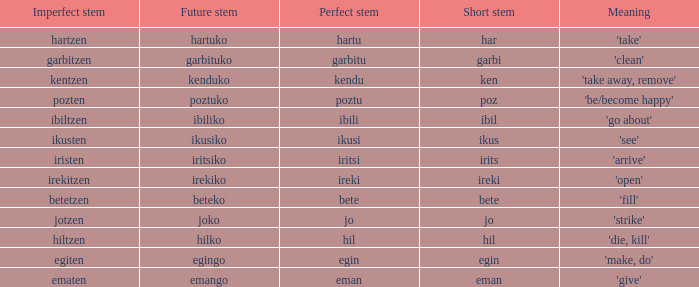Name the perfect stem for jo 1.0. Could you parse the entire table as a dict? {'header': ['Imperfect stem', 'Future stem', 'Perfect stem', 'Short stem', 'Meaning'], 'rows': [['hartzen', 'hartuko', 'hartu', 'har', "'take'"], ['garbitzen', 'garbituko', 'garbitu', 'garbi', "'clean'"], ['kentzen', 'kenduko', 'kendu', 'ken', "'take away, remove'"], ['pozten', 'poztuko', 'poztu', 'poz', "'be/become happy'"], ['ibiltzen', 'ibiliko', 'ibili', 'ibil', "'go about'"], ['ikusten', 'ikusiko', 'ikusi', 'ikus', "'see'"], ['iristen', 'iritsiko', 'iritsi', 'irits', "'arrive'"], ['irekitzen', 'irekiko', 'ireki', 'ireki', "'open'"], ['betetzen', 'beteko', 'bete', 'bete', "'fill'"], ['jotzen', 'joko', 'jo', 'jo', "'strike'"], ['hiltzen', 'hilko', 'hil', 'hil', "'die, kill'"], ['egiten', 'egingo', 'egin', 'egin', "'make, do'"], ['ematen', 'emango', 'eman', 'eman', "'give'"]]} 